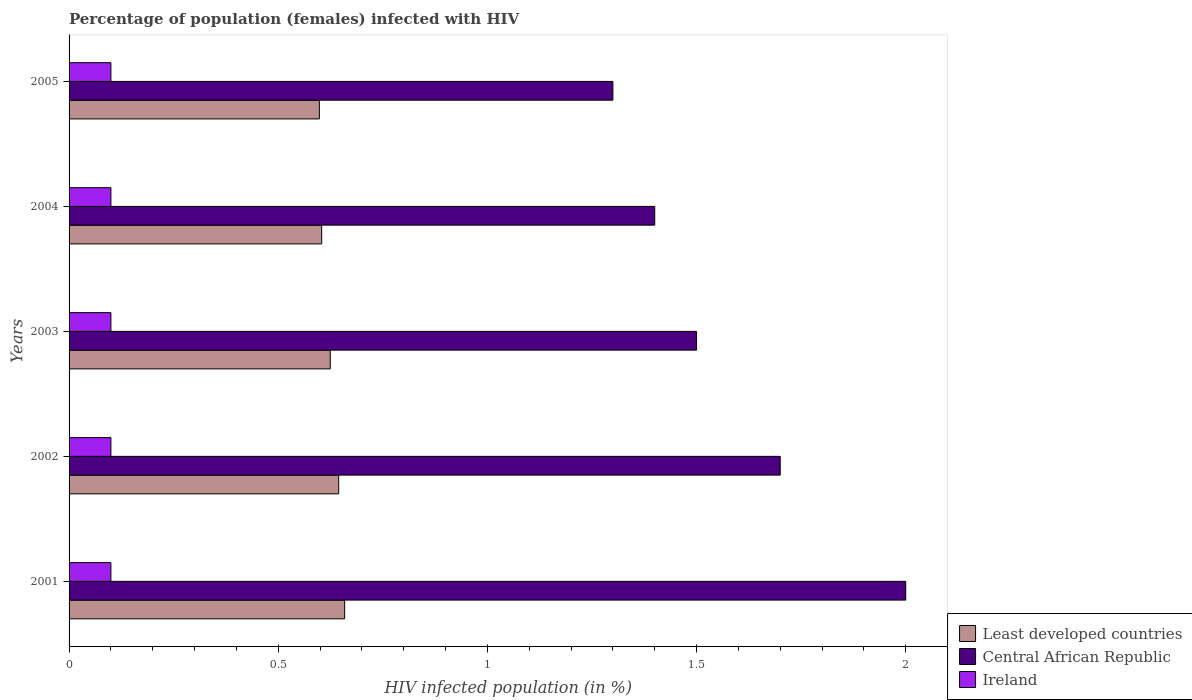Are the number of bars per tick equal to the number of legend labels?
Make the answer very short. Yes. How many bars are there on the 3rd tick from the top?
Your response must be concise. 3. How many bars are there on the 1st tick from the bottom?
Your response must be concise. 3. What is the percentage of HIV infected female population in Central African Republic in 2001?
Give a very brief answer. 2. Across all years, what is the maximum percentage of HIV infected female population in Least developed countries?
Keep it short and to the point. 0.66. Across all years, what is the minimum percentage of HIV infected female population in Least developed countries?
Your response must be concise. 0.6. In which year was the percentage of HIV infected female population in Central African Republic minimum?
Your response must be concise. 2005. What is the total percentage of HIV infected female population in Least developed countries in the graph?
Your answer should be compact. 3.13. What is the difference between the percentage of HIV infected female population in Central African Republic in 2003 and that in 2005?
Your answer should be very brief. 0.2. What is the difference between the percentage of HIV infected female population in Central African Republic in 2004 and the percentage of HIV infected female population in Least developed countries in 2005?
Ensure brevity in your answer.  0.8. What is the average percentage of HIV infected female population in Least developed countries per year?
Your answer should be very brief. 0.63. In the year 2005, what is the difference between the percentage of HIV infected female population in Central African Republic and percentage of HIV infected female population in Least developed countries?
Keep it short and to the point. 0.7. In how many years, is the percentage of HIV infected female population in Central African Republic greater than 1.4 %?
Give a very brief answer. 3. What is the ratio of the percentage of HIV infected female population in Central African Republic in 2001 to that in 2003?
Your response must be concise. 1.33. What is the difference between the highest and the second highest percentage of HIV infected female population in Central African Republic?
Your response must be concise. 0.3. What is the difference between the highest and the lowest percentage of HIV infected female population in Least developed countries?
Provide a succinct answer. 0.06. What does the 2nd bar from the top in 2005 represents?
Keep it short and to the point. Central African Republic. What does the 1st bar from the bottom in 2004 represents?
Give a very brief answer. Least developed countries. Is it the case that in every year, the sum of the percentage of HIV infected female population in Central African Republic and percentage of HIV infected female population in Least developed countries is greater than the percentage of HIV infected female population in Ireland?
Your answer should be very brief. Yes. How many bars are there?
Keep it short and to the point. 15. How many years are there in the graph?
Give a very brief answer. 5. Are the values on the major ticks of X-axis written in scientific E-notation?
Your response must be concise. No. Does the graph contain grids?
Your answer should be very brief. No. Where does the legend appear in the graph?
Your answer should be compact. Bottom right. How many legend labels are there?
Offer a terse response. 3. How are the legend labels stacked?
Your response must be concise. Vertical. What is the title of the graph?
Your answer should be compact. Percentage of population (females) infected with HIV. Does "Korea (Republic)" appear as one of the legend labels in the graph?
Make the answer very short. No. What is the label or title of the X-axis?
Ensure brevity in your answer.  HIV infected population (in %). What is the HIV infected population (in %) of Least developed countries in 2001?
Provide a short and direct response. 0.66. What is the HIV infected population (in %) in Central African Republic in 2001?
Make the answer very short. 2. What is the HIV infected population (in %) in Least developed countries in 2002?
Your answer should be compact. 0.64. What is the HIV infected population (in %) of Central African Republic in 2002?
Keep it short and to the point. 1.7. What is the HIV infected population (in %) in Least developed countries in 2003?
Offer a terse response. 0.62. What is the HIV infected population (in %) in Central African Republic in 2003?
Give a very brief answer. 1.5. What is the HIV infected population (in %) in Ireland in 2003?
Offer a very short reply. 0.1. What is the HIV infected population (in %) of Least developed countries in 2004?
Keep it short and to the point. 0.6. What is the HIV infected population (in %) in Central African Republic in 2004?
Provide a short and direct response. 1.4. What is the HIV infected population (in %) in Least developed countries in 2005?
Provide a succinct answer. 0.6. What is the HIV infected population (in %) in Central African Republic in 2005?
Make the answer very short. 1.3. Across all years, what is the maximum HIV infected population (in %) in Least developed countries?
Provide a short and direct response. 0.66. Across all years, what is the minimum HIV infected population (in %) in Least developed countries?
Your answer should be compact. 0.6. Across all years, what is the minimum HIV infected population (in %) in Central African Republic?
Make the answer very short. 1.3. Across all years, what is the minimum HIV infected population (in %) of Ireland?
Give a very brief answer. 0.1. What is the total HIV infected population (in %) in Least developed countries in the graph?
Make the answer very short. 3.13. What is the total HIV infected population (in %) of Central African Republic in the graph?
Your response must be concise. 7.9. What is the difference between the HIV infected population (in %) in Least developed countries in 2001 and that in 2002?
Make the answer very short. 0.01. What is the difference between the HIV infected population (in %) in Central African Republic in 2001 and that in 2002?
Provide a succinct answer. 0.3. What is the difference between the HIV infected population (in %) of Ireland in 2001 and that in 2002?
Ensure brevity in your answer.  0. What is the difference between the HIV infected population (in %) of Least developed countries in 2001 and that in 2003?
Keep it short and to the point. 0.03. What is the difference between the HIV infected population (in %) of Least developed countries in 2001 and that in 2004?
Your answer should be very brief. 0.05. What is the difference between the HIV infected population (in %) of Central African Republic in 2001 and that in 2004?
Keep it short and to the point. 0.6. What is the difference between the HIV infected population (in %) of Least developed countries in 2001 and that in 2005?
Keep it short and to the point. 0.06. What is the difference between the HIV infected population (in %) of Central African Republic in 2001 and that in 2005?
Your answer should be compact. 0.7. What is the difference between the HIV infected population (in %) of Least developed countries in 2002 and that in 2003?
Give a very brief answer. 0.02. What is the difference between the HIV infected population (in %) in Central African Republic in 2002 and that in 2003?
Make the answer very short. 0.2. What is the difference between the HIV infected population (in %) of Ireland in 2002 and that in 2003?
Offer a terse response. 0. What is the difference between the HIV infected population (in %) of Least developed countries in 2002 and that in 2004?
Offer a very short reply. 0.04. What is the difference between the HIV infected population (in %) of Ireland in 2002 and that in 2004?
Provide a short and direct response. 0. What is the difference between the HIV infected population (in %) of Least developed countries in 2002 and that in 2005?
Provide a succinct answer. 0.05. What is the difference between the HIV infected population (in %) of Central African Republic in 2002 and that in 2005?
Ensure brevity in your answer.  0.4. What is the difference between the HIV infected population (in %) of Least developed countries in 2003 and that in 2004?
Give a very brief answer. 0.02. What is the difference between the HIV infected population (in %) in Central African Republic in 2003 and that in 2004?
Offer a very short reply. 0.1. What is the difference between the HIV infected population (in %) of Least developed countries in 2003 and that in 2005?
Keep it short and to the point. 0.03. What is the difference between the HIV infected population (in %) in Least developed countries in 2004 and that in 2005?
Keep it short and to the point. 0.01. What is the difference between the HIV infected population (in %) in Central African Republic in 2004 and that in 2005?
Your answer should be compact. 0.1. What is the difference between the HIV infected population (in %) in Least developed countries in 2001 and the HIV infected population (in %) in Central African Republic in 2002?
Provide a succinct answer. -1.04. What is the difference between the HIV infected population (in %) of Least developed countries in 2001 and the HIV infected population (in %) of Ireland in 2002?
Ensure brevity in your answer.  0.56. What is the difference between the HIV infected population (in %) of Central African Republic in 2001 and the HIV infected population (in %) of Ireland in 2002?
Ensure brevity in your answer.  1.9. What is the difference between the HIV infected population (in %) in Least developed countries in 2001 and the HIV infected population (in %) in Central African Republic in 2003?
Give a very brief answer. -0.84. What is the difference between the HIV infected population (in %) in Least developed countries in 2001 and the HIV infected population (in %) in Ireland in 2003?
Keep it short and to the point. 0.56. What is the difference between the HIV infected population (in %) of Central African Republic in 2001 and the HIV infected population (in %) of Ireland in 2003?
Make the answer very short. 1.9. What is the difference between the HIV infected population (in %) in Least developed countries in 2001 and the HIV infected population (in %) in Central African Republic in 2004?
Your answer should be very brief. -0.74. What is the difference between the HIV infected population (in %) of Least developed countries in 2001 and the HIV infected population (in %) of Ireland in 2004?
Give a very brief answer. 0.56. What is the difference between the HIV infected population (in %) of Central African Republic in 2001 and the HIV infected population (in %) of Ireland in 2004?
Your response must be concise. 1.9. What is the difference between the HIV infected population (in %) in Least developed countries in 2001 and the HIV infected population (in %) in Central African Republic in 2005?
Offer a terse response. -0.64. What is the difference between the HIV infected population (in %) in Least developed countries in 2001 and the HIV infected population (in %) in Ireland in 2005?
Ensure brevity in your answer.  0.56. What is the difference between the HIV infected population (in %) in Least developed countries in 2002 and the HIV infected population (in %) in Central African Republic in 2003?
Your answer should be compact. -0.86. What is the difference between the HIV infected population (in %) in Least developed countries in 2002 and the HIV infected population (in %) in Ireland in 2003?
Offer a terse response. 0.54. What is the difference between the HIV infected population (in %) of Least developed countries in 2002 and the HIV infected population (in %) of Central African Republic in 2004?
Offer a terse response. -0.76. What is the difference between the HIV infected population (in %) in Least developed countries in 2002 and the HIV infected population (in %) in Ireland in 2004?
Make the answer very short. 0.54. What is the difference between the HIV infected population (in %) in Least developed countries in 2002 and the HIV infected population (in %) in Central African Republic in 2005?
Your response must be concise. -0.66. What is the difference between the HIV infected population (in %) in Least developed countries in 2002 and the HIV infected population (in %) in Ireland in 2005?
Ensure brevity in your answer.  0.54. What is the difference between the HIV infected population (in %) of Least developed countries in 2003 and the HIV infected population (in %) of Central African Republic in 2004?
Make the answer very short. -0.78. What is the difference between the HIV infected population (in %) in Least developed countries in 2003 and the HIV infected population (in %) in Ireland in 2004?
Make the answer very short. 0.52. What is the difference between the HIV infected population (in %) of Least developed countries in 2003 and the HIV infected population (in %) of Central African Republic in 2005?
Ensure brevity in your answer.  -0.68. What is the difference between the HIV infected population (in %) in Least developed countries in 2003 and the HIV infected population (in %) in Ireland in 2005?
Make the answer very short. 0.52. What is the difference between the HIV infected population (in %) of Least developed countries in 2004 and the HIV infected population (in %) of Central African Republic in 2005?
Provide a short and direct response. -0.7. What is the difference between the HIV infected population (in %) of Least developed countries in 2004 and the HIV infected population (in %) of Ireland in 2005?
Give a very brief answer. 0.5. What is the difference between the HIV infected population (in %) of Central African Republic in 2004 and the HIV infected population (in %) of Ireland in 2005?
Keep it short and to the point. 1.3. What is the average HIV infected population (in %) of Least developed countries per year?
Keep it short and to the point. 0.63. What is the average HIV infected population (in %) of Central African Republic per year?
Provide a succinct answer. 1.58. In the year 2001, what is the difference between the HIV infected population (in %) in Least developed countries and HIV infected population (in %) in Central African Republic?
Your answer should be compact. -1.34. In the year 2001, what is the difference between the HIV infected population (in %) of Least developed countries and HIV infected population (in %) of Ireland?
Make the answer very short. 0.56. In the year 2001, what is the difference between the HIV infected population (in %) of Central African Republic and HIV infected population (in %) of Ireland?
Your answer should be very brief. 1.9. In the year 2002, what is the difference between the HIV infected population (in %) in Least developed countries and HIV infected population (in %) in Central African Republic?
Offer a terse response. -1.06. In the year 2002, what is the difference between the HIV infected population (in %) in Least developed countries and HIV infected population (in %) in Ireland?
Your answer should be very brief. 0.54. In the year 2003, what is the difference between the HIV infected population (in %) in Least developed countries and HIV infected population (in %) in Central African Republic?
Make the answer very short. -0.88. In the year 2003, what is the difference between the HIV infected population (in %) in Least developed countries and HIV infected population (in %) in Ireland?
Ensure brevity in your answer.  0.52. In the year 2003, what is the difference between the HIV infected population (in %) of Central African Republic and HIV infected population (in %) of Ireland?
Make the answer very short. 1.4. In the year 2004, what is the difference between the HIV infected population (in %) in Least developed countries and HIV infected population (in %) in Central African Republic?
Your response must be concise. -0.8. In the year 2004, what is the difference between the HIV infected population (in %) in Least developed countries and HIV infected population (in %) in Ireland?
Your answer should be very brief. 0.5. In the year 2004, what is the difference between the HIV infected population (in %) in Central African Republic and HIV infected population (in %) in Ireland?
Provide a succinct answer. 1.3. In the year 2005, what is the difference between the HIV infected population (in %) in Least developed countries and HIV infected population (in %) in Central African Republic?
Provide a succinct answer. -0.7. In the year 2005, what is the difference between the HIV infected population (in %) in Least developed countries and HIV infected population (in %) in Ireland?
Your answer should be compact. 0.5. What is the ratio of the HIV infected population (in %) of Least developed countries in 2001 to that in 2002?
Your answer should be very brief. 1.02. What is the ratio of the HIV infected population (in %) in Central African Republic in 2001 to that in 2002?
Provide a succinct answer. 1.18. What is the ratio of the HIV infected population (in %) of Ireland in 2001 to that in 2002?
Your answer should be compact. 1. What is the ratio of the HIV infected population (in %) of Least developed countries in 2001 to that in 2003?
Ensure brevity in your answer.  1.06. What is the ratio of the HIV infected population (in %) of Ireland in 2001 to that in 2003?
Provide a short and direct response. 1. What is the ratio of the HIV infected population (in %) in Least developed countries in 2001 to that in 2004?
Provide a short and direct response. 1.09. What is the ratio of the HIV infected population (in %) of Central African Republic in 2001 to that in 2004?
Give a very brief answer. 1.43. What is the ratio of the HIV infected population (in %) of Least developed countries in 2001 to that in 2005?
Your response must be concise. 1.1. What is the ratio of the HIV infected population (in %) of Central African Republic in 2001 to that in 2005?
Keep it short and to the point. 1.54. What is the ratio of the HIV infected population (in %) of Least developed countries in 2002 to that in 2003?
Offer a very short reply. 1.03. What is the ratio of the HIV infected population (in %) in Central African Republic in 2002 to that in 2003?
Provide a succinct answer. 1.13. What is the ratio of the HIV infected population (in %) in Least developed countries in 2002 to that in 2004?
Your answer should be very brief. 1.07. What is the ratio of the HIV infected population (in %) in Central African Republic in 2002 to that in 2004?
Offer a terse response. 1.21. What is the ratio of the HIV infected population (in %) of Least developed countries in 2002 to that in 2005?
Your response must be concise. 1.08. What is the ratio of the HIV infected population (in %) of Central African Republic in 2002 to that in 2005?
Your response must be concise. 1.31. What is the ratio of the HIV infected population (in %) in Ireland in 2002 to that in 2005?
Make the answer very short. 1. What is the ratio of the HIV infected population (in %) in Least developed countries in 2003 to that in 2004?
Your answer should be very brief. 1.03. What is the ratio of the HIV infected population (in %) of Central African Republic in 2003 to that in 2004?
Provide a short and direct response. 1.07. What is the ratio of the HIV infected population (in %) in Ireland in 2003 to that in 2004?
Keep it short and to the point. 1. What is the ratio of the HIV infected population (in %) of Least developed countries in 2003 to that in 2005?
Make the answer very short. 1.04. What is the ratio of the HIV infected population (in %) of Central African Republic in 2003 to that in 2005?
Offer a very short reply. 1.15. What is the ratio of the HIV infected population (in %) in Ireland in 2003 to that in 2005?
Provide a succinct answer. 1. What is the ratio of the HIV infected population (in %) in Least developed countries in 2004 to that in 2005?
Provide a succinct answer. 1.01. What is the ratio of the HIV infected population (in %) of Central African Republic in 2004 to that in 2005?
Provide a short and direct response. 1.08. What is the difference between the highest and the second highest HIV infected population (in %) in Least developed countries?
Keep it short and to the point. 0.01. What is the difference between the highest and the second highest HIV infected population (in %) in Ireland?
Your response must be concise. 0. What is the difference between the highest and the lowest HIV infected population (in %) of Least developed countries?
Your response must be concise. 0.06. 